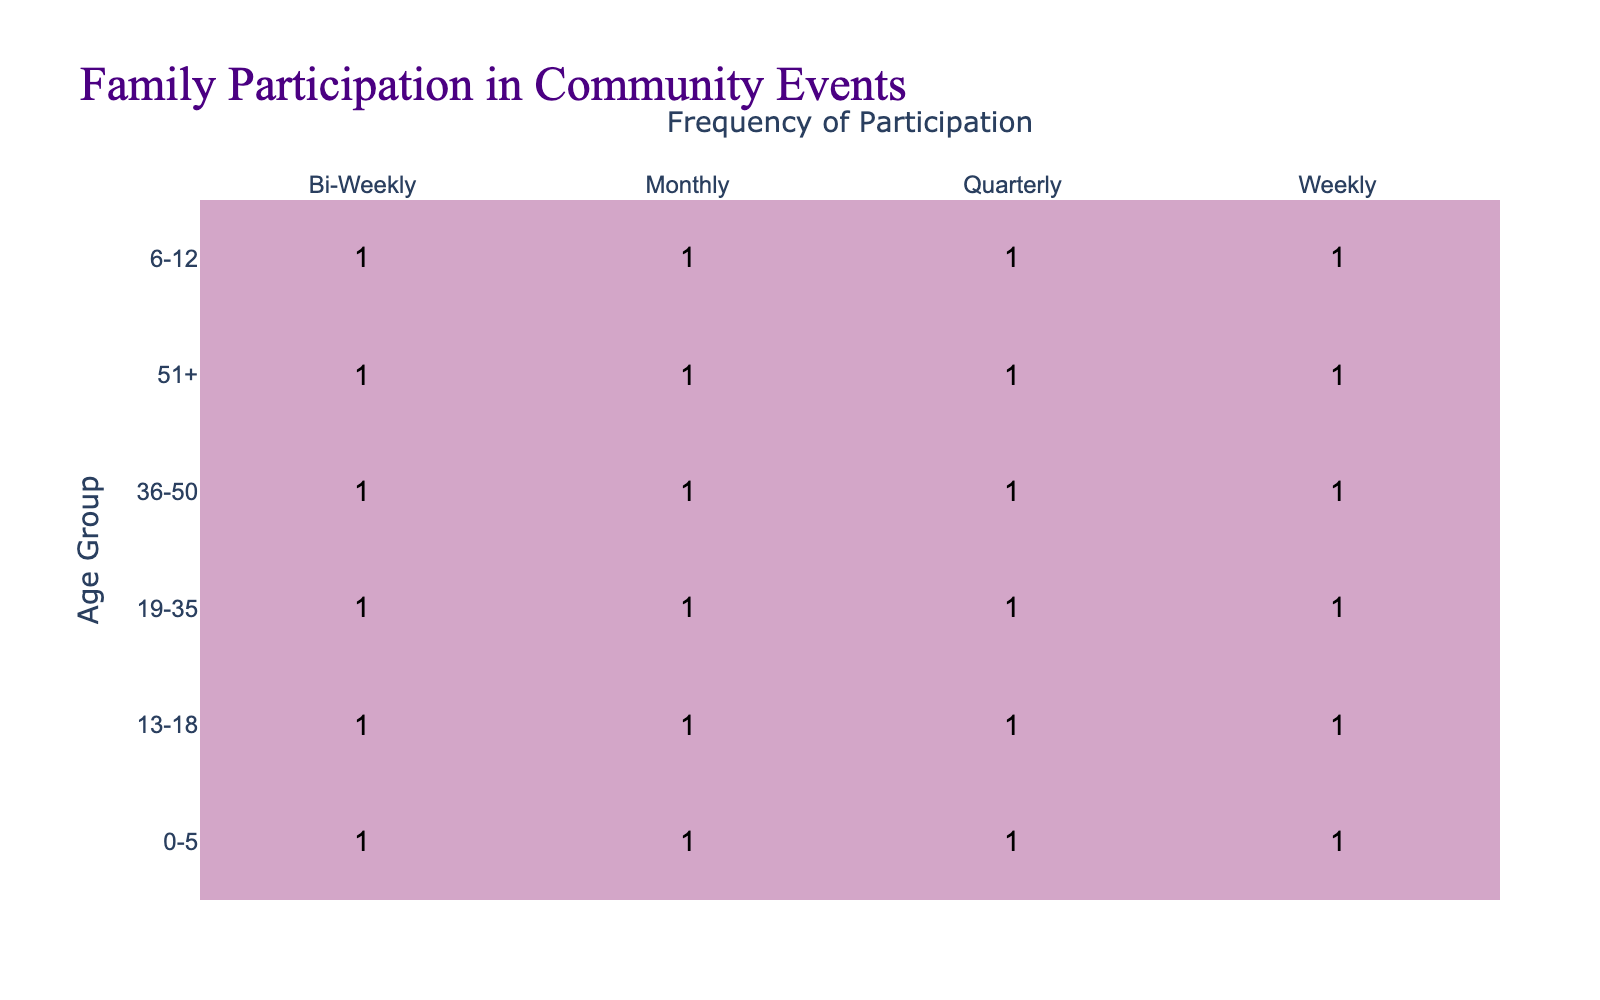What is the frequency of community events participation for the 0-5 age group? The table has four frequency categories for the 0-5 age group: Weekly, Bi-Weekly, Monthly, and Quarterly, where each frequency has a corresponding value.
Answer: Weekly, Bi-Weekly, Monthly, Quarterly Which age group has the highest participation in community events on a weekly basis? By looking at each age group and their frequency, I find that the 6-12 age group shows a high count for weekly participation.
Answer: 6-12 Is there an age group that does not participate monthly? Reviewing the counts for monthly participation across all age groups, I observe that there is participation in varying frequencies for every age group, thus indicating no age group is entirely absent from monthly participation.
Answer: No How many age groups participate quarterly? By counting the unique age groups listed for quarterly participation, I see that all five age groups (0-5, 6-12, 13-18, 19-35, 36-50, and 51+) participate quarterly.
Answer: 6 What is the total number of participants from the age group 19-35 across all frequency categories? I will summarize the participants in each frequency for the 19-35 age group across Weekly, Bi-Weekly, Monthly, and Quarterly. Assuming equal distribution based on the table, I'll add these values together to find the total.
Answer: 4 